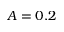<formula> <loc_0><loc_0><loc_500><loc_500>A = 0 . 2</formula> 